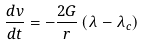<formula> <loc_0><loc_0><loc_500><loc_500>\frac { d v } { d t } = - \frac { 2 G } { r } \left ( \lambda - \lambda _ { c } \right )</formula> 